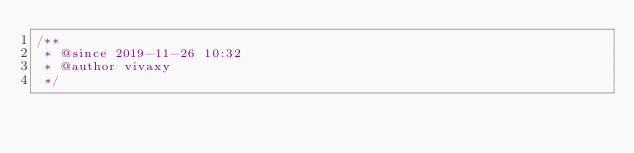<code> <loc_0><loc_0><loc_500><loc_500><_JavaScript_>/**
 * @since 2019-11-26 10:32
 * @author vivaxy
 */</code> 